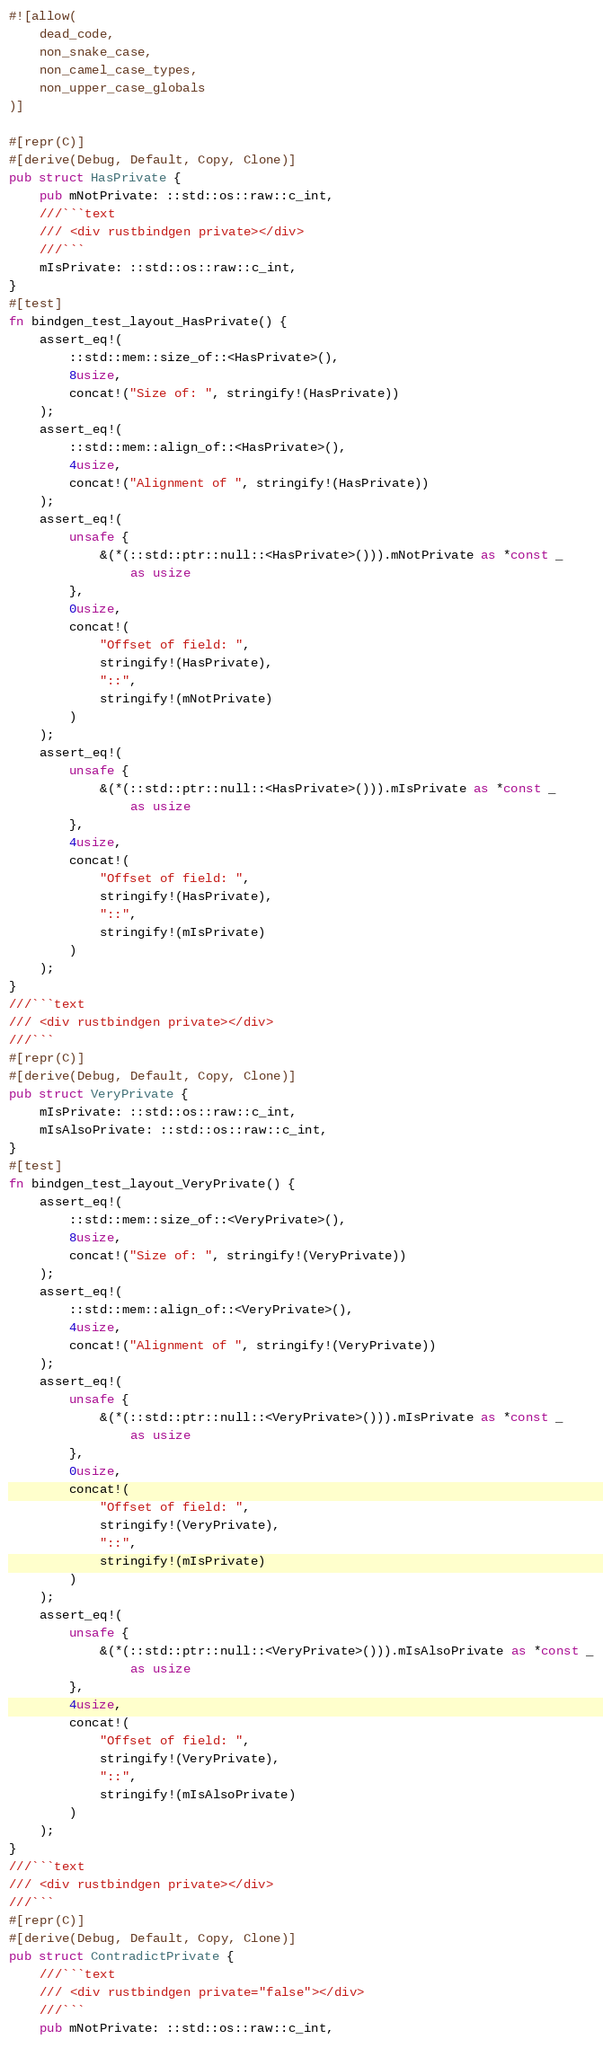<code> <loc_0><loc_0><loc_500><loc_500><_Rust_>#![allow(
    dead_code,
    non_snake_case,
    non_camel_case_types,
    non_upper_case_globals
)]

#[repr(C)]
#[derive(Debug, Default, Copy, Clone)]
pub struct HasPrivate {
    pub mNotPrivate: ::std::os::raw::c_int,
    ///```text
    /// <div rustbindgen private></div>
    ///```
    mIsPrivate: ::std::os::raw::c_int,
}
#[test]
fn bindgen_test_layout_HasPrivate() {
    assert_eq!(
        ::std::mem::size_of::<HasPrivate>(),
        8usize,
        concat!("Size of: ", stringify!(HasPrivate))
    );
    assert_eq!(
        ::std::mem::align_of::<HasPrivate>(),
        4usize,
        concat!("Alignment of ", stringify!(HasPrivate))
    );
    assert_eq!(
        unsafe {
            &(*(::std::ptr::null::<HasPrivate>())).mNotPrivate as *const _
                as usize
        },
        0usize,
        concat!(
            "Offset of field: ",
            stringify!(HasPrivate),
            "::",
            stringify!(mNotPrivate)
        )
    );
    assert_eq!(
        unsafe {
            &(*(::std::ptr::null::<HasPrivate>())).mIsPrivate as *const _
                as usize
        },
        4usize,
        concat!(
            "Offset of field: ",
            stringify!(HasPrivate),
            "::",
            stringify!(mIsPrivate)
        )
    );
}
///```text
/// <div rustbindgen private></div>
///```
#[repr(C)]
#[derive(Debug, Default, Copy, Clone)]
pub struct VeryPrivate {
    mIsPrivate: ::std::os::raw::c_int,
    mIsAlsoPrivate: ::std::os::raw::c_int,
}
#[test]
fn bindgen_test_layout_VeryPrivate() {
    assert_eq!(
        ::std::mem::size_of::<VeryPrivate>(),
        8usize,
        concat!("Size of: ", stringify!(VeryPrivate))
    );
    assert_eq!(
        ::std::mem::align_of::<VeryPrivate>(),
        4usize,
        concat!("Alignment of ", stringify!(VeryPrivate))
    );
    assert_eq!(
        unsafe {
            &(*(::std::ptr::null::<VeryPrivate>())).mIsPrivate as *const _
                as usize
        },
        0usize,
        concat!(
            "Offset of field: ",
            stringify!(VeryPrivate),
            "::",
            stringify!(mIsPrivate)
        )
    );
    assert_eq!(
        unsafe {
            &(*(::std::ptr::null::<VeryPrivate>())).mIsAlsoPrivate as *const _
                as usize
        },
        4usize,
        concat!(
            "Offset of field: ",
            stringify!(VeryPrivate),
            "::",
            stringify!(mIsAlsoPrivate)
        )
    );
}
///```text
/// <div rustbindgen private></div>
///```
#[repr(C)]
#[derive(Debug, Default, Copy, Clone)]
pub struct ContradictPrivate {
    ///```text
    /// <div rustbindgen private="false"></div>
    ///```
    pub mNotPrivate: ::std::os::raw::c_int,</code> 